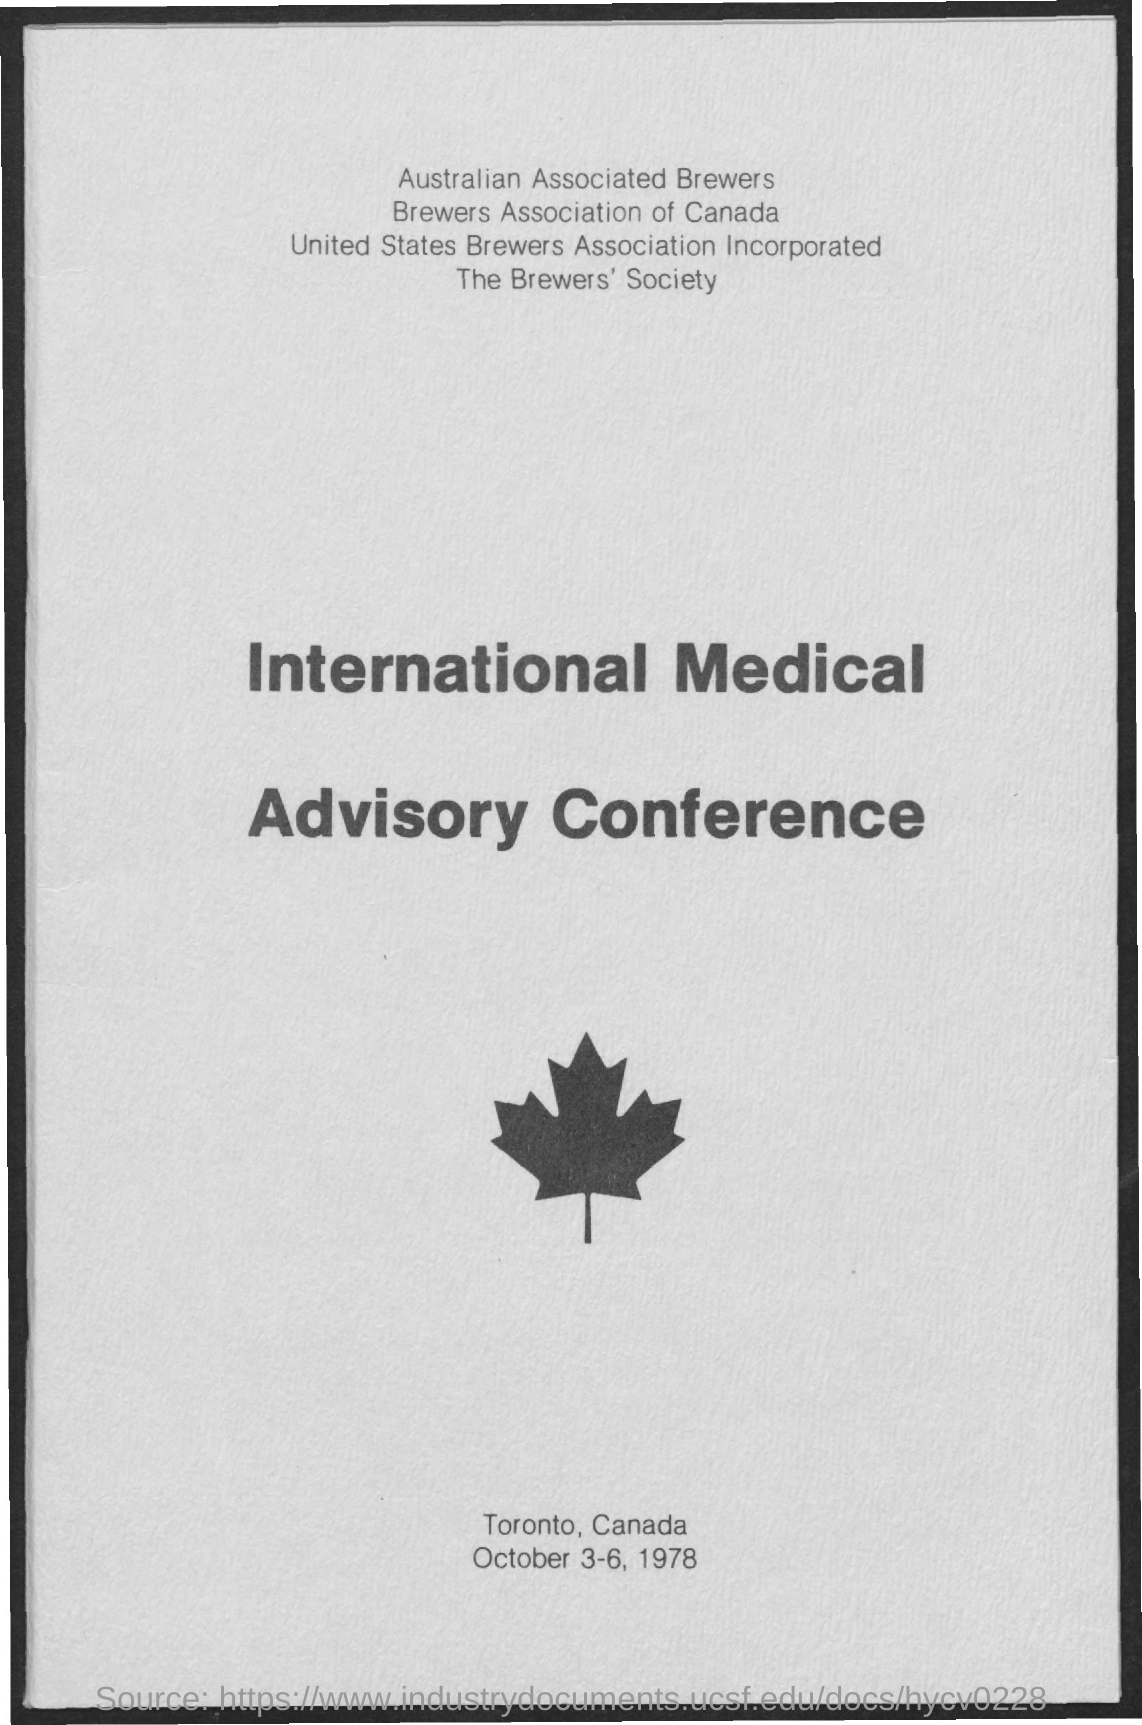Outline some significant characteristics in this image. The conference mentioned is called the Advisory Conference. The Brewer's Society is the name of the society mentioned. The date mentioned is October 3-6, 1978. 